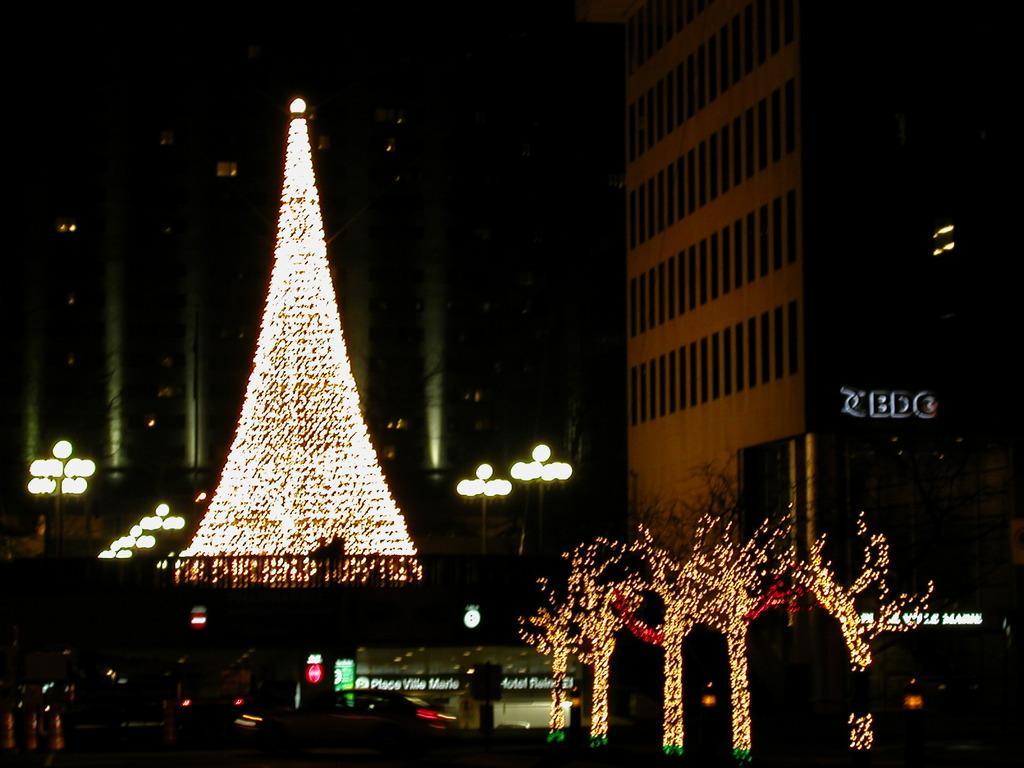In one or two sentences, can you explain what this image depicts? In this picture we can see few lights, trees, poles, hoardings and buildings. 